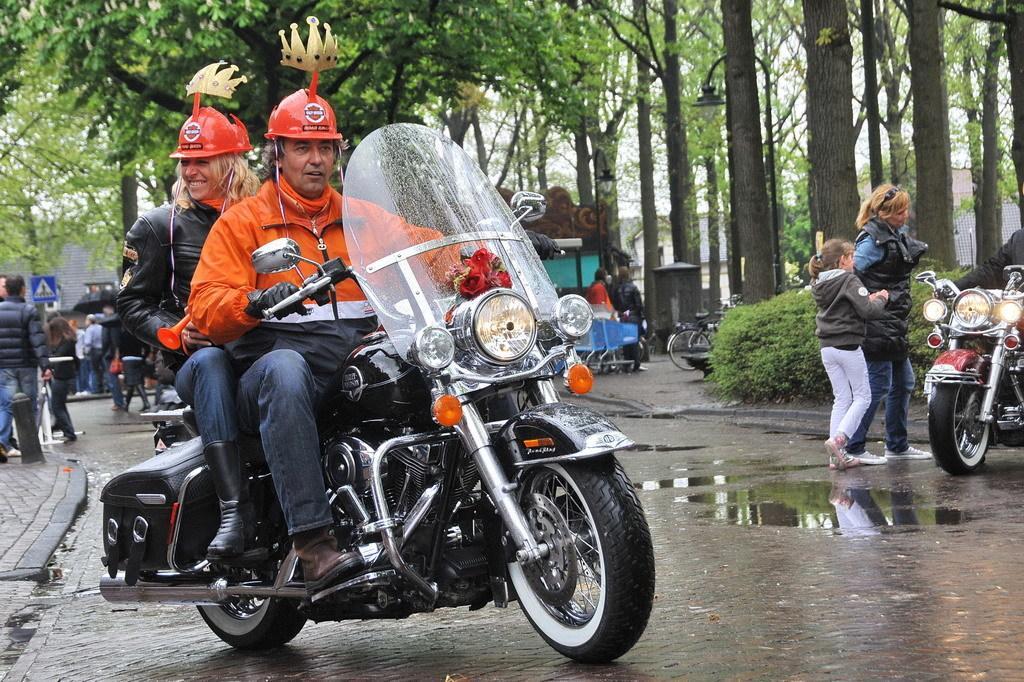In one or two sentences, can you explain what this image depicts? There is a man and woman sitting on a bike which is on the road. There is another bike, on the right hand side of the image. Beside that bike, a woman and girl are walking. On the right hand side, there is a footpath. In the background, there are group of people, a sign a tree. On the right hand side of the background, there are group of trees, plant and bicycle. 